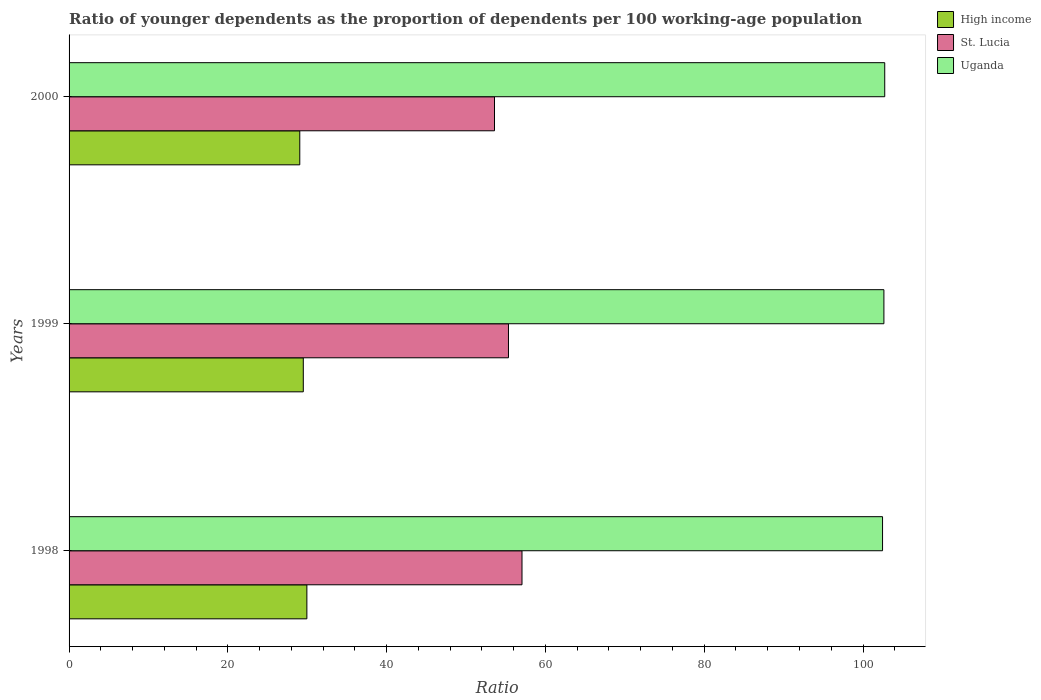How many different coloured bars are there?
Make the answer very short. 3. How many bars are there on the 3rd tick from the top?
Give a very brief answer. 3. How many bars are there on the 1st tick from the bottom?
Your answer should be compact. 3. In how many cases, is the number of bars for a given year not equal to the number of legend labels?
Offer a very short reply. 0. What is the age dependency ratio(young) in St. Lucia in 2000?
Provide a short and direct response. 53.59. Across all years, what is the maximum age dependency ratio(young) in St. Lucia?
Keep it short and to the point. 57.05. Across all years, what is the minimum age dependency ratio(young) in St. Lucia?
Offer a terse response. 53.59. In which year was the age dependency ratio(young) in Uganda maximum?
Keep it short and to the point. 2000. In which year was the age dependency ratio(young) in Uganda minimum?
Your response must be concise. 1998. What is the total age dependency ratio(young) in Uganda in the graph?
Offer a very short reply. 307.84. What is the difference between the age dependency ratio(young) in St. Lucia in 1999 and that in 2000?
Your response must be concise. 1.76. What is the difference between the age dependency ratio(young) in High income in 2000 and the age dependency ratio(young) in Uganda in 1999?
Give a very brief answer. -73.57. What is the average age dependency ratio(young) in St. Lucia per year?
Your response must be concise. 55.33. In the year 2000, what is the difference between the age dependency ratio(young) in St. Lucia and age dependency ratio(young) in High income?
Provide a succinct answer. 24.53. In how many years, is the age dependency ratio(young) in St. Lucia greater than 20 ?
Provide a short and direct response. 3. What is the ratio of the age dependency ratio(young) in Uganda in 1998 to that in 1999?
Provide a succinct answer. 1. Is the age dependency ratio(young) in High income in 1999 less than that in 2000?
Keep it short and to the point. No. What is the difference between the highest and the second highest age dependency ratio(young) in High income?
Your answer should be compact. 0.45. What is the difference between the highest and the lowest age dependency ratio(young) in High income?
Your response must be concise. 0.89. In how many years, is the age dependency ratio(young) in High income greater than the average age dependency ratio(young) in High income taken over all years?
Ensure brevity in your answer.  1. Is the sum of the age dependency ratio(young) in High income in 1999 and 2000 greater than the maximum age dependency ratio(young) in Uganda across all years?
Offer a very short reply. No. What does the 2nd bar from the bottom in 1998 represents?
Your response must be concise. St. Lucia. How many bars are there?
Provide a short and direct response. 9. Are all the bars in the graph horizontal?
Offer a very short reply. Yes. How many years are there in the graph?
Your answer should be very brief. 3. Are the values on the major ticks of X-axis written in scientific E-notation?
Offer a terse response. No. Does the graph contain any zero values?
Provide a succinct answer. No. Where does the legend appear in the graph?
Your response must be concise. Top right. How many legend labels are there?
Offer a terse response. 3. What is the title of the graph?
Make the answer very short. Ratio of younger dependents as the proportion of dependents per 100 working-age population. Does "Latvia" appear as one of the legend labels in the graph?
Provide a succinct answer. No. What is the label or title of the X-axis?
Ensure brevity in your answer.  Ratio. What is the Ratio in High income in 1998?
Offer a very short reply. 29.95. What is the Ratio in St. Lucia in 1998?
Provide a short and direct response. 57.05. What is the Ratio in Uganda in 1998?
Offer a very short reply. 102.46. What is the Ratio in High income in 1999?
Offer a terse response. 29.5. What is the Ratio of St. Lucia in 1999?
Provide a short and direct response. 55.34. What is the Ratio in Uganda in 1999?
Your response must be concise. 102.63. What is the Ratio in High income in 2000?
Provide a succinct answer. 29.06. What is the Ratio in St. Lucia in 2000?
Provide a short and direct response. 53.59. What is the Ratio of Uganda in 2000?
Ensure brevity in your answer.  102.74. Across all years, what is the maximum Ratio of High income?
Provide a short and direct response. 29.95. Across all years, what is the maximum Ratio of St. Lucia?
Offer a terse response. 57.05. Across all years, what is the maximum Ratio in Uganda?
Your answer should be very brief. 102.74. Across all years, what is the minimum Ratio in High income?
Your answer should be very brief. 29.06. Across all years, what is the minimum Ratio in St. Lucia?
Your answer should be compact. 53.59. Across all years, what is the minimum Ratio in Uganda?
Ensure brevity in your answer.  102.46. What is the total Ratio of High income in the graph?
Your answer should be very brief. 88.51. What is the total Ratio of St. Lucia in the graph?
Provide a short and direct response. 165.98. What is the total Ratio of Uganda in the graph?
Your response must be concise. 307.84. What is the difference between the Ratio of High income in 1998 and that in 1999?
Keep it short and to the point. 0.45. What is the difference between the Ratio of St. Lucia in 1998 and that in 1999?
Make the answer very short. 1.71. What is the difference between the Ratio of Uganda in 1998 and that in 1999?
Your response must be concise. -0.17. What is the difference between the Ratio in High income in 1998 and that in 2000?
Keep it short and to the point. 0.89. What is the difference between the Ratio of St. Lucia in 1998 and that in 2000?
Provide a succinct answer. 3.46. What is the difference between the Ratio in Uganda in 1998 and that in 2000?
Your answer should be very brief. -0.28. What is the difference between the Ratio of High income in 1999 and that in 2000?
Your answer should be very brief. 0.44. What is the difference between the Ratio of St. Lucia in 1999 and that in 2000?
Keep it short and to the point. 1.76. What is the difference between the Ratio of Uganda in 1999 and that in 2000?
Give a very brief answer. -0.1. What is the difference between the Ratio of High income in 1998 and the Ratio of St. Lucia in 1999?
Your response must be concise. -25.39. What is the difference between the Ratio of High income in 1998 and the Ratio of Uganda in 1999?
Ensure brevity in your answer.  -72.68. What is the difference between the Ratio in St. Lucia in 1998 and the Ratio in Uganda in 1999?
Offer a very short reply. -45.58. What is the difference between the Ratio of High income in 1998 and the Ratio of St. Lucia in 2000?
Your answer should be compact. -23.63. What is the difference between the Ratio in High income in 1998 and the Ratio in Uganda in 2000?
Your answer should be compact. -72.79. What is the difference between the Ratio in St. Lucia in 1998 and the Ratio in Uganda in 2000?
Your answer should be compact. -45.69. What is the difference between the Ratio of High income in 1999 and the Ratio of St. Lucia in 2000?
Offer a terse response. -24.08. What is the difference between the Ratio of High income in 1999 and the Ratio of Uganda in 2000?
Offer a very short reply. -73.24. What is the difference between the Ratio in St. Lucia in 1999 and the Ratio in Uganda in 2000?
Your answer should be compact. -47.39. What is the average Ratio in High income per year?
Offer a very short reply. 29.5. What is the average Ratio of St. Lucia per year?
Offer a terse response. 55.33. What is the average Ratio in Uganda per year?
Your answer should be compact. 102.61. In the year 1998, what is the difference between the Ratio in High income and Ratio in St. Lucia?
Make the answer very short. -27.1. In the year 1998, what is the difference between the Ratio in High income and Ratio in Uganda?
Keep it short and to the point. -72.51. In the year 1998, what is the difference between the Ratio of St. Lucia and Ratio of Uganda?
Make the answer very short. -45.41. In the year 1999, what is the difference between the Ratio in High income and Ratio in St. Lucia?
Your answer should be compact. -25.84. In the year 1999, what is the difference between the Ratio of High income and Ratio of Uganda?
Provide a succinct answer. -73.13. In the year 1999, what is the difference between the Ratio in St. Lucia and Ratio in Uganda?
Make the answer very short. -47.29. In the year 2000, what is the difference between the Ratio in High income and Ratio in St. Lucia?
Your answer should be very brief. -24.53. In the year 2000, what is the difference between the Ratio of High income and Ratio of Uganda?
Make the answer very short. -73.68. In the year 2000, what is the difference between the Ratio in St. Lucia and Ratio in Uganda?
Make the answer very short. -49.15. What is the ratio of the Ratio in High income in 1998 to that in 1999?
Your answer should be very brief. 1.02. What is the ratio of the Ratio of St. Lucia in 1998 to that in 1999?
Ensure brevity in your answer.  1.03. What is the ratio of the Ratio of Uganda in 1998 to that in 1999?
Your answer should be very brief. 1. What is the ratio of the Ratio of High income in 1998 to that in 2000?
Provide a succinct answer. 1.03. What is the ratio of the Ratio of St. Lucia in 1998 to that in 2000?
Offer a very short reply. 1.06. What is the ratio of the Ratio in High income in 1999 to that in 2000?
Your answer should be very brief. 1.02. What is the ratio of the Ratio in St. Lucia in 1999 to that in 2000?
Your response must be concise. 1.03. What is the ratio of the Ratio in Uganda in 1999 to that in 2000?
Offer a very short reply. 1. What is the difference between the highest and the second highest Ratio in High income?
Make the answer very short. 0.45. What is the difference between the highest and the second highest Ratio of St. Lucia?
Offer a terse response. 1.71. What is the difference between the highest and the second highest Ratio in Uganda?
Provide a short and direct response. 0.1. What is the difference between the highest and the lowest Ratio of High income?
Your answer should be compact. 0.89. What is the difference between the highest and the lowest Ratio of St. Lucia?
Your response must be concise. 3.46. What is the difference between the highest and the lowest Ratio of Uganda?
Offer a terse response. 0.28. 